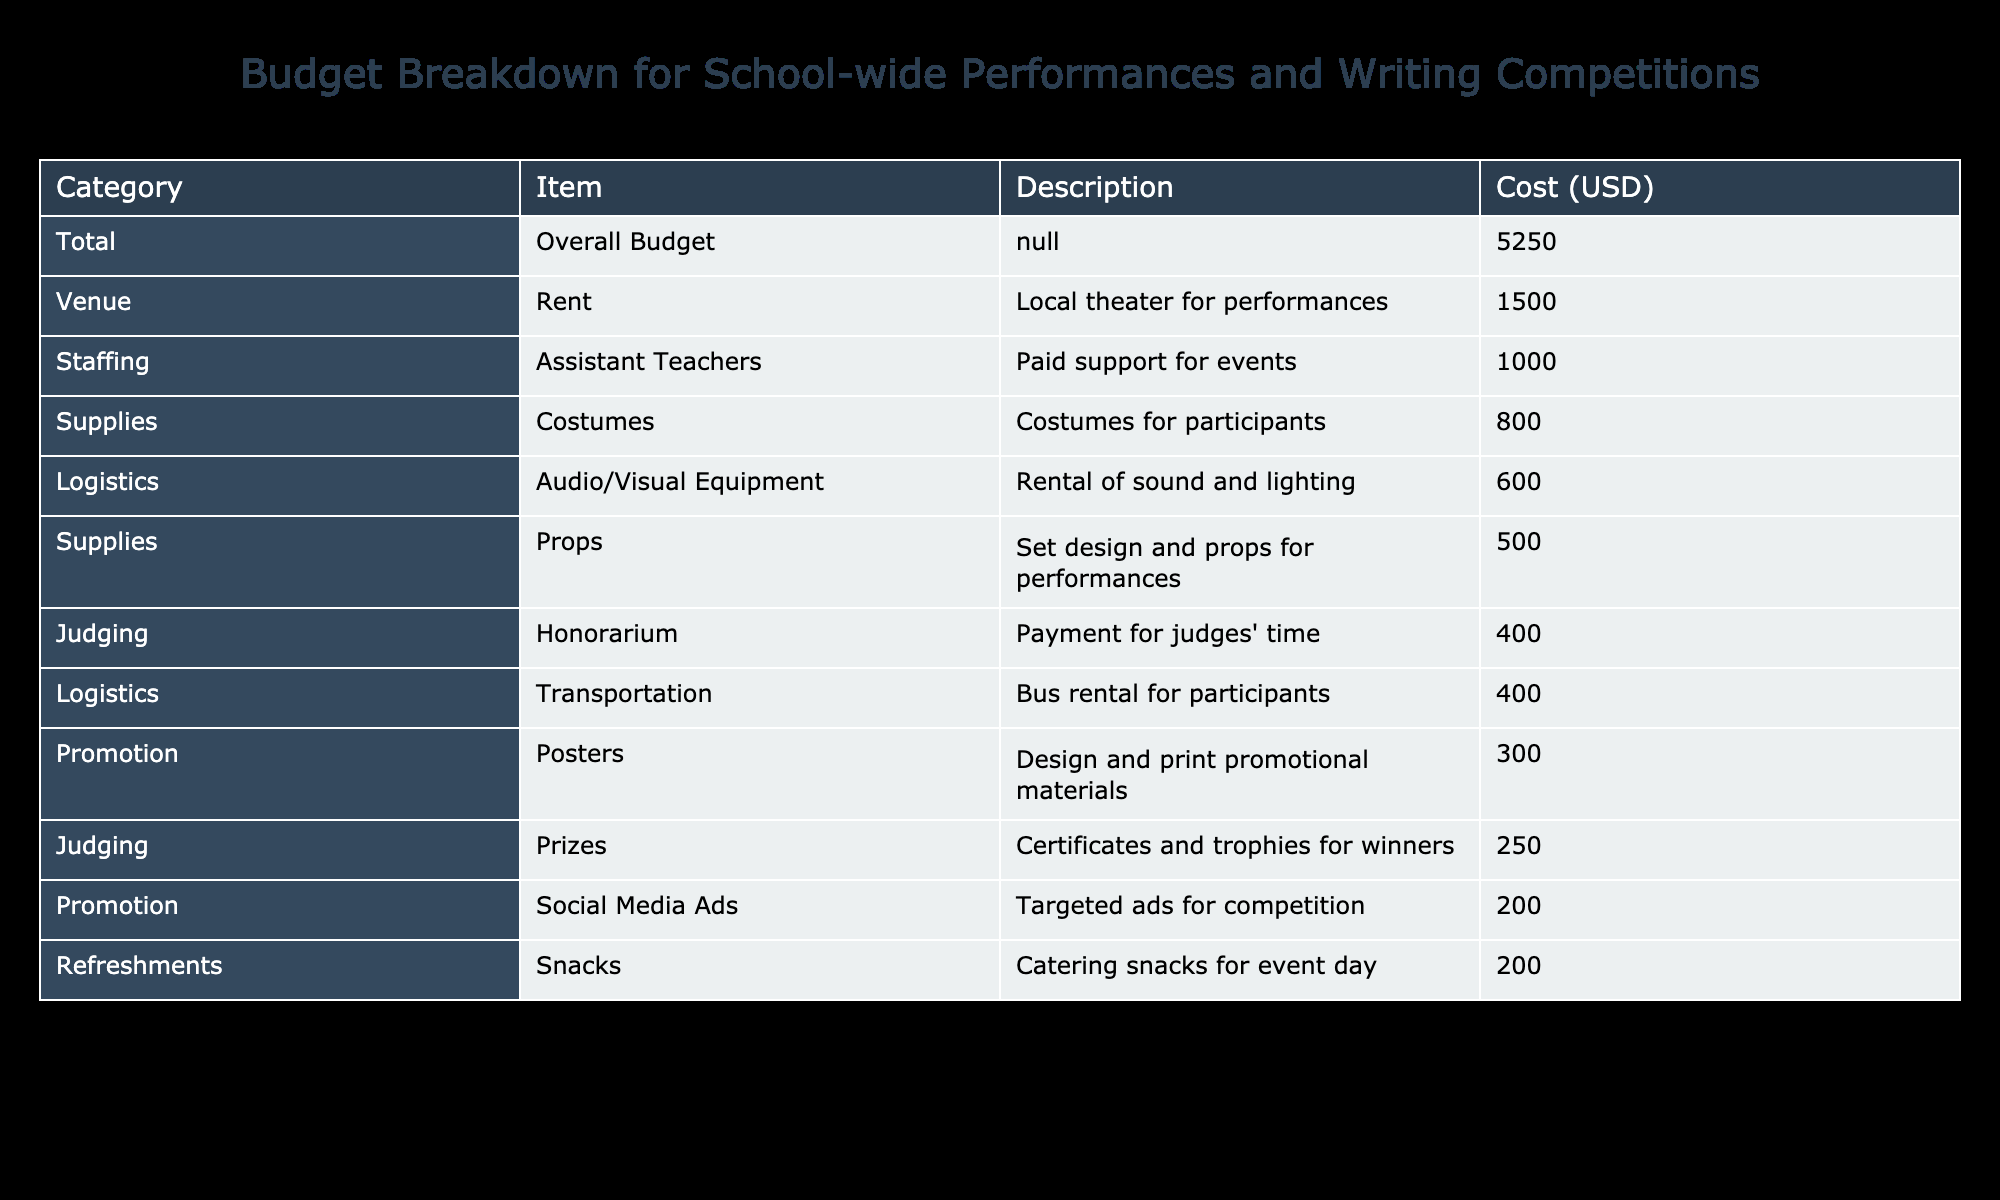What is the total cost for renting the venue? The table states that the cost for venue rent is 1500 USD.
Answer: 1500 USD Which category has the highest expenditure? Upon reviewing the table, the category with the highest expenditure is Supplies, totaling 1300 USD (800 for costumes and 500 for props).
Answer: Supplies What is the cost of transportation? The transportation cost is listed as 400 USD in the Logistics category.
Answer: 400 USD Are snacks included in the budget for refreshments? Yes, the table indicates that catering snacks for event day is part of the budget, costing 200 USD.
Answer: Yes What is the total amount spent in the Judging category? The Judging category includes prizes and honorarium, contributing to a total expense of 650 USD (250 for prizes and 400 for honorarium).
Answer: 650 USD If we remove the cost of refreshments from the total budget, what would the new total be? The overall budget is 5250 USD. If we subtract the refreshments cost of 200 USD, the new total is 5050 USD (5250 - 200 = 5050).
Answer: 5050 USD What percentage of the total budget is allocated for Supplies? The total budget is 5250 USD, and the Supplies category costs 1300 USD. To find the percentage, divide 1300 by 5250 and multiply by 100, resulting in approximately 24.76%.
Answer: 24.76% Are there any expenses related to audio/visual equipment? Yes, the table notes that there is an expense of 600 USD for the rental of audio/visual equipment under Logistics.
Answer: Yes If we combine the costs from the Promotion and Supplies categories, what is the total? The Promotion category totals 500 USD (300 for posters and 200 for ads), while the Supplies category totals 1300 USD (800 for costumes and 500 for props). Adding these results gives us 1800 USD (500 + 1300 = 1800).
Answer: 1800 USD 